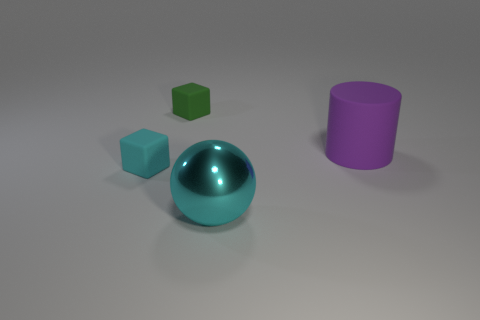What number of objects are either big cylinders or small things?
Ensure brevity in your answer.  3. There is a large thing that is in front of the small cyan object; does it have the same color as the tiny rubber block behind the large purple cylinder?
Provide a short and direct response. No. How many other things are the same shape as the large matte thing?
Make the answer very short. 0. Is there a tiny green object?
Keep it short and to the point. Yes. How many objects are either purple objects or objects on the right side of the small cyan matte block?
Your response must be concise. 3. Is the size of the cube behind the purple matte object the same as the matte cylinder?
Your response must be concise. No. How many other objects are the same size as the cyan sphere?
Provide a short and direct response. 1. The big shiny sphere is what color?
Make the answer very short. Cyan. What material is the block in front of the tiny green rubber cube?
Make the answer very short. Rubber. Are there an equal number of tiny matte blocks that are on the right side of the large purple matte object and large objects?
Provide a short and direct response. No. 